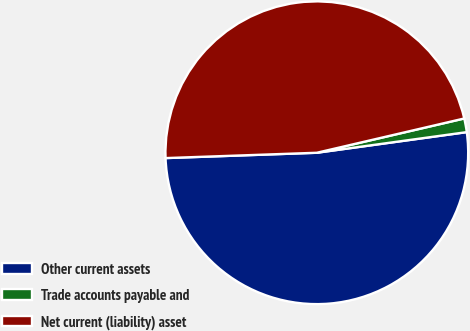<chart> <loc_0><loc_0><loc_500><loc_500><pie_chart><fcel>Other current assets<fcel>Trade accounts payable and<fcel>Net current (liability) asset<nl><fcel>51.61%<fcel>1.46%<fcel>46.92%<nl></chart> 